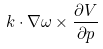Convert formula to latex. <formula><loc_0><loc_0><loc_500><loc_500>k \cdot \nabla \omega \times \frac { \partial V } { \partial p }</formula> 